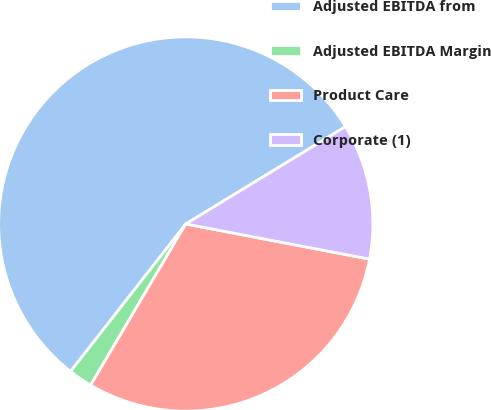Convert chart. <chart><loc_0><loc_0><loc_500><loc_500><pie_chart><fcel>Adjusted EBITDA from<fcel>Adjusted EBITDA Margin<fcel>Product Care<fcel>Corporate (1)<nl><fcel>55.73%<fcel>2.07%<fcel>30.48%<fcel>11.72%<nl></chart> 